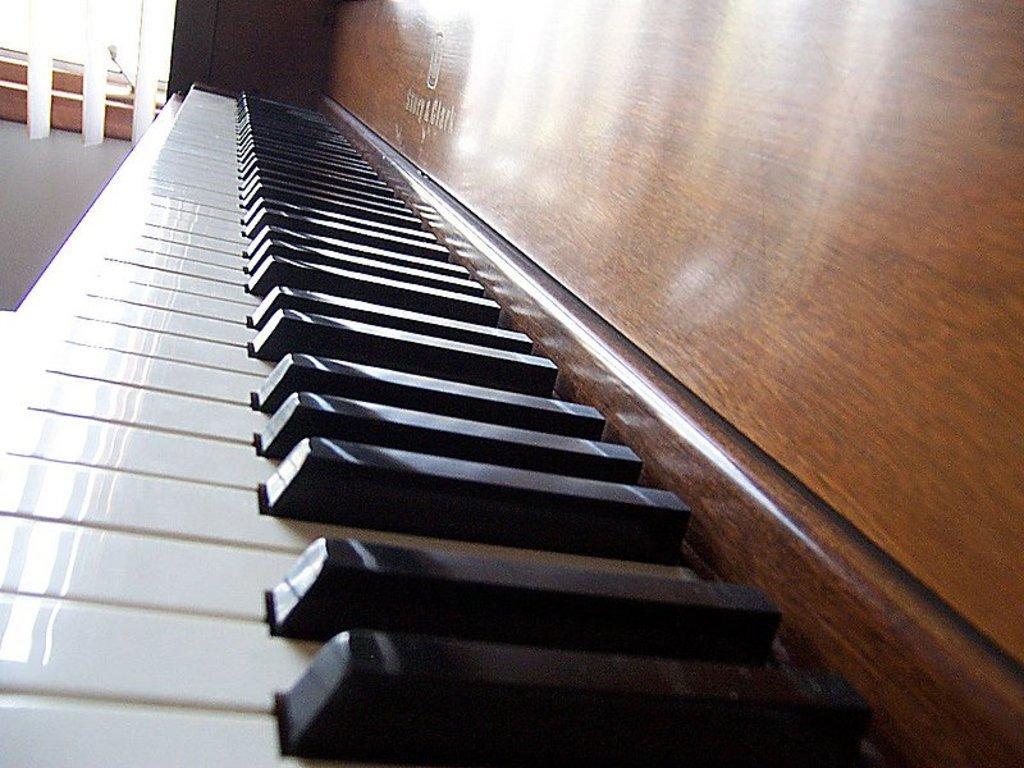Describe this image in one or two sentences. In this image i can see a piano attached to a wooden wall. 